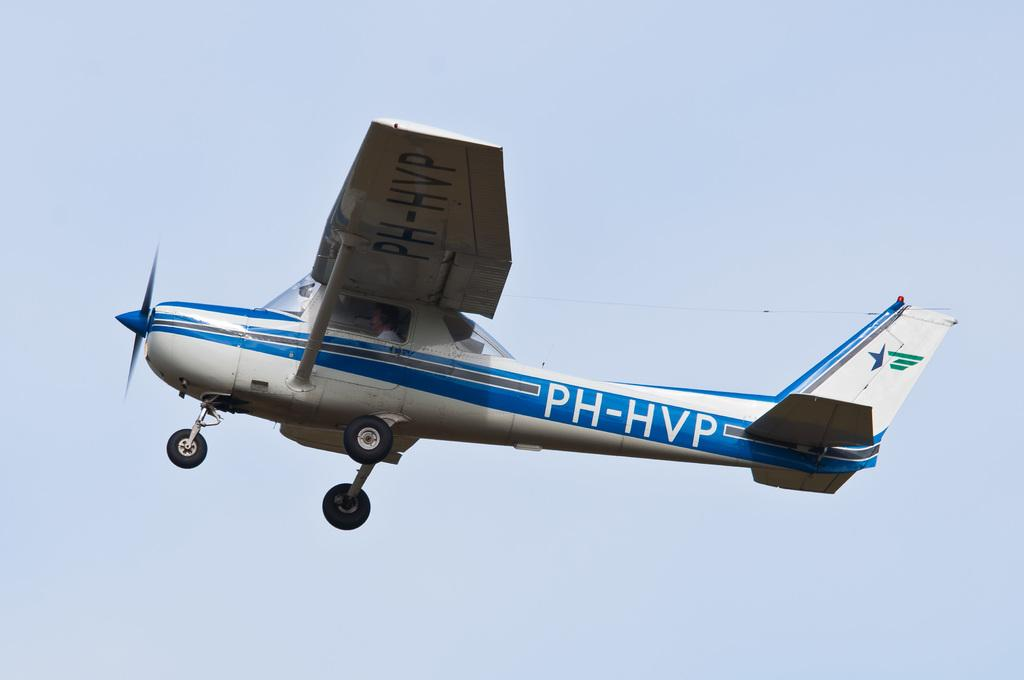What is the main subject of the image? The main subject of the image is an aircraft. Can you describe the person inside the aircraft? A person is sitting inside the aircraft. What is written on the aircraft? There is text written on the aircraft. What can be seen in the background of the image? The sky is visible in the background of the image. Can you see any squirrels hanging from a cord in the image? There are no squirrels or cords present in the image. 